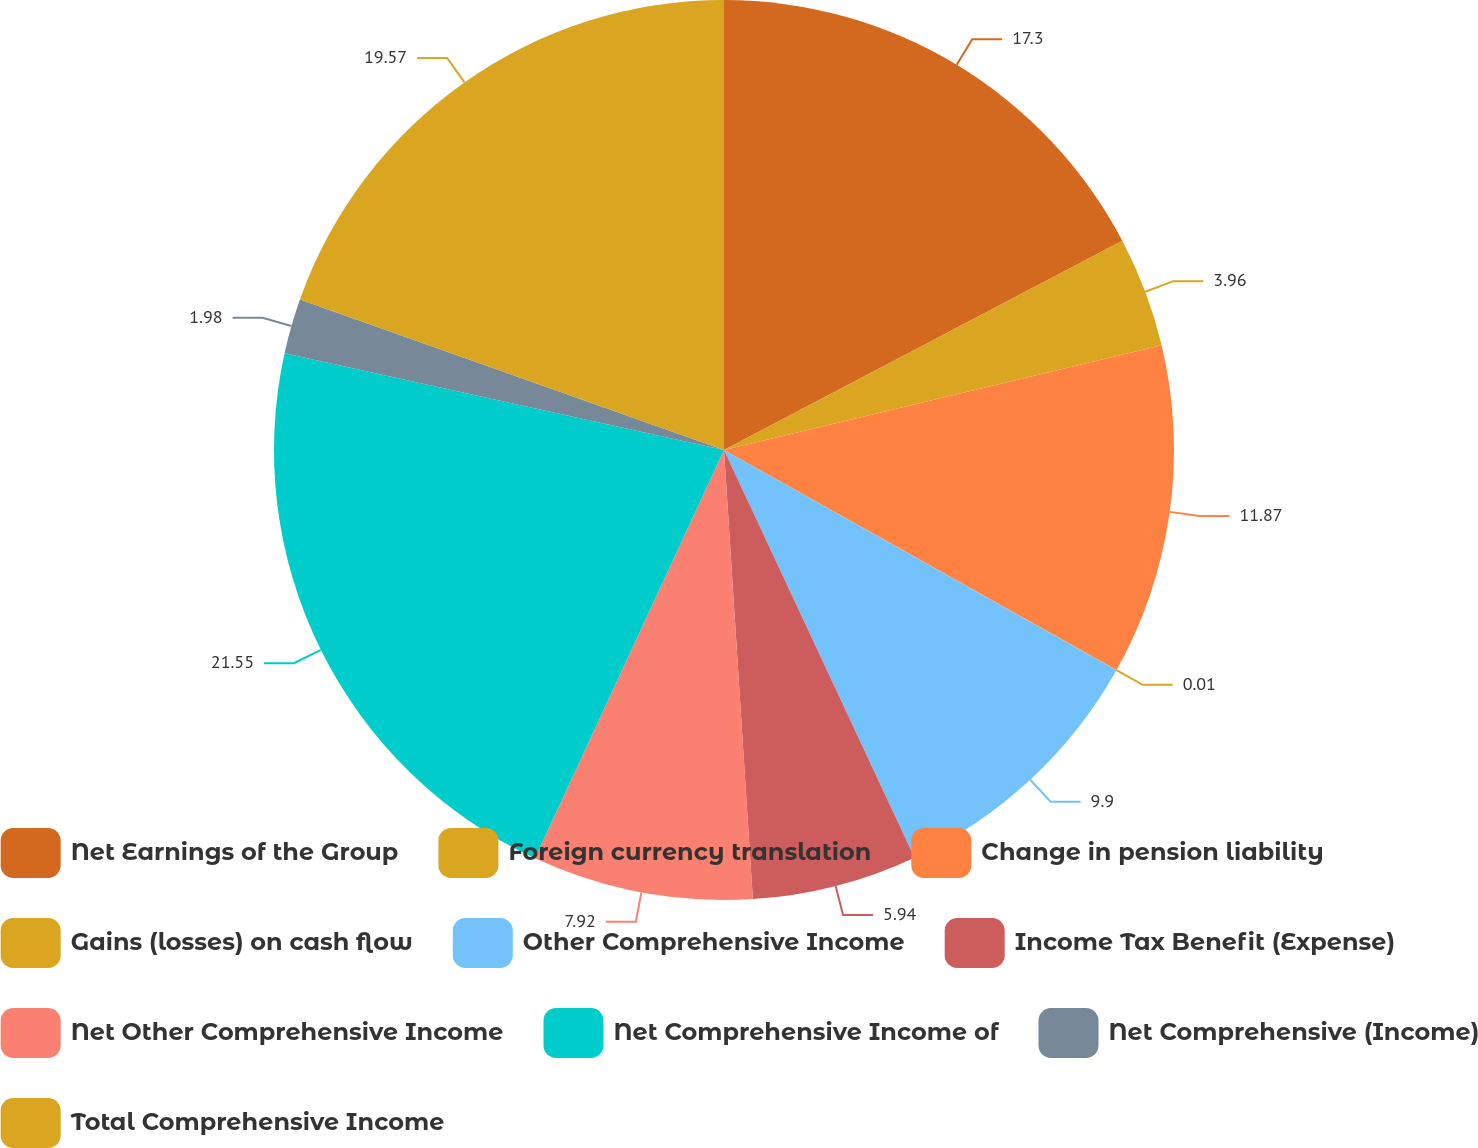<chart> <loc_0><loc_0><loc_500><loc_500><pie_chart><fcel>Net Earnings of the Group<fcel>Foreign currency translation<fcel>Change in pension liability<fcel>Gains (losses) on cash flow<fcel>Other Comprehensive Income<fcel>Income Tax Benefit (Expense)<fcel>Net Other Comprehensive Income<fcel>Net Comprehensive Income of<fcel>Net Comprehensive (Income)<fcel>Total Comprehensive Income<nl><fcel>17.3%<fcel>3.96%<fcel>11.87%<fcel>0.01%<fcel>9.9%<fcel>5.94%<fcel>7.92%<fcel>21.55%<fcel>1.98%<fcel>19.57%<nl></chart> 